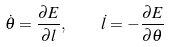<formula> <loc_0><loc_0><loc_500><loc_500>\dot { \theta } = \frac { \partial E } { \partial l } , \quad \dot { l } = - \frac { \partial E } { \partial \theta }</formula> 